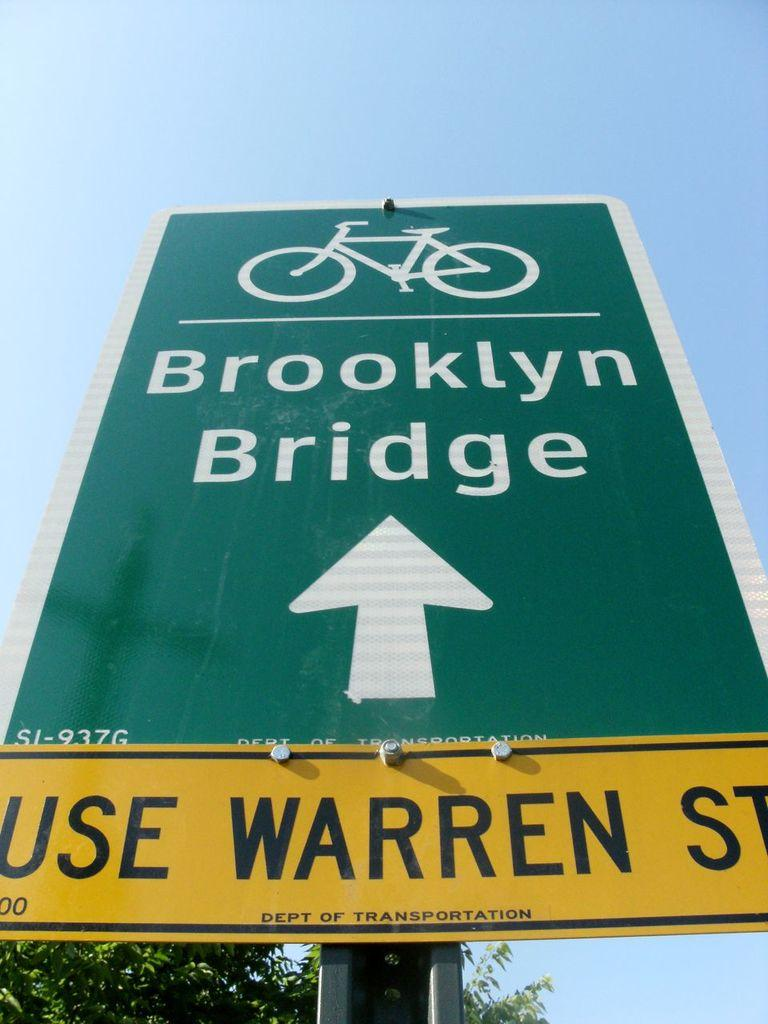<image>
Create a compact narrative representing the image presented. a road sign saying bike route to Brooklyn Bridge 